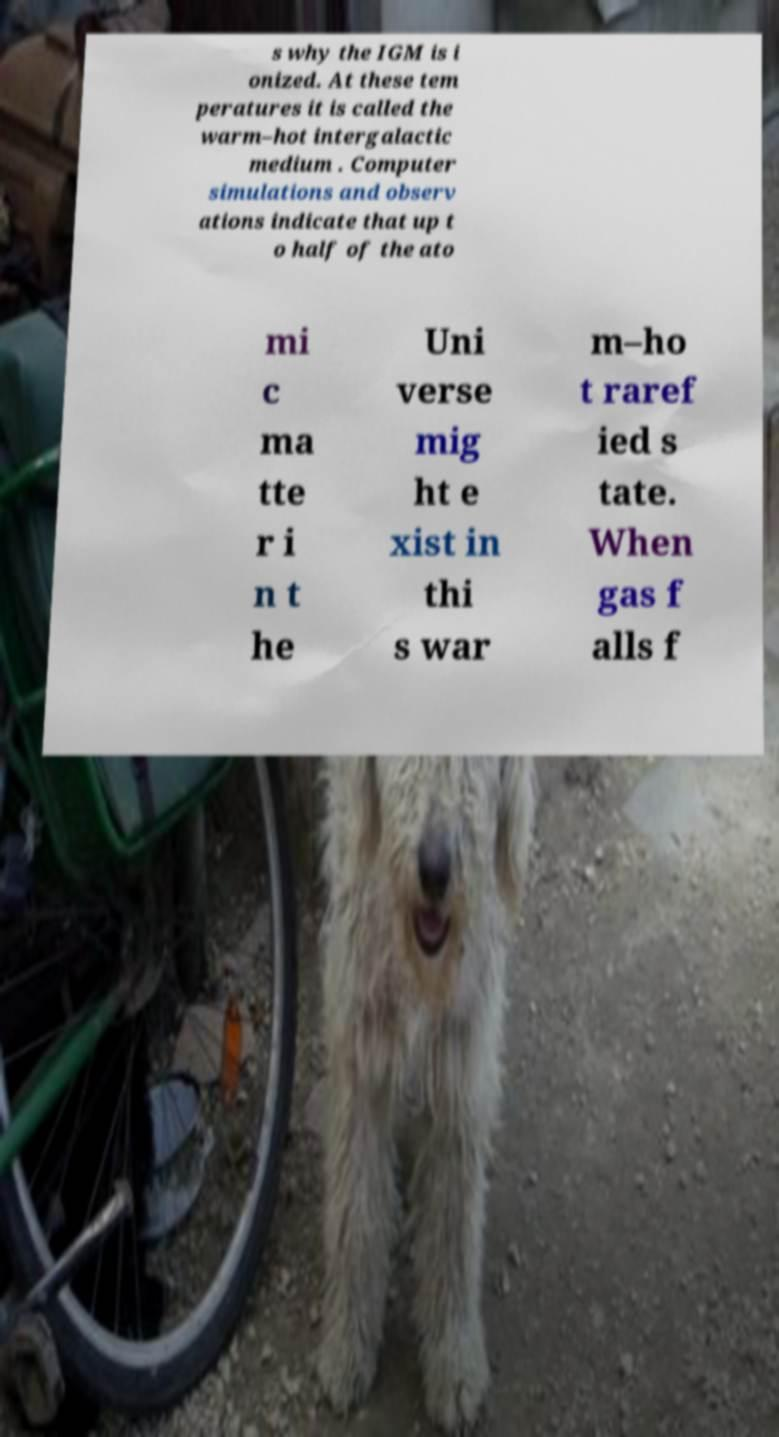There's text embedded in this image that I need extracted. Can you transcribe it verbatim? s why the IGM is i onized. At these tem peratures it is called the warm–hot intergalactic medium . Computer simulations and observ ations indicate that up t o half of the ato mi c ma tte r i n t he Uni verse mig ht e xist in thi s war m–ho t raref ied s tate. When gas f alls f 